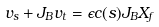<formula> <loc_0><loc_0><loc_500><loc_500>v _ { s } + J _ { B } v _ { t } = \epsilon c ( s ) J _ { B } X _ { f }</formula> 